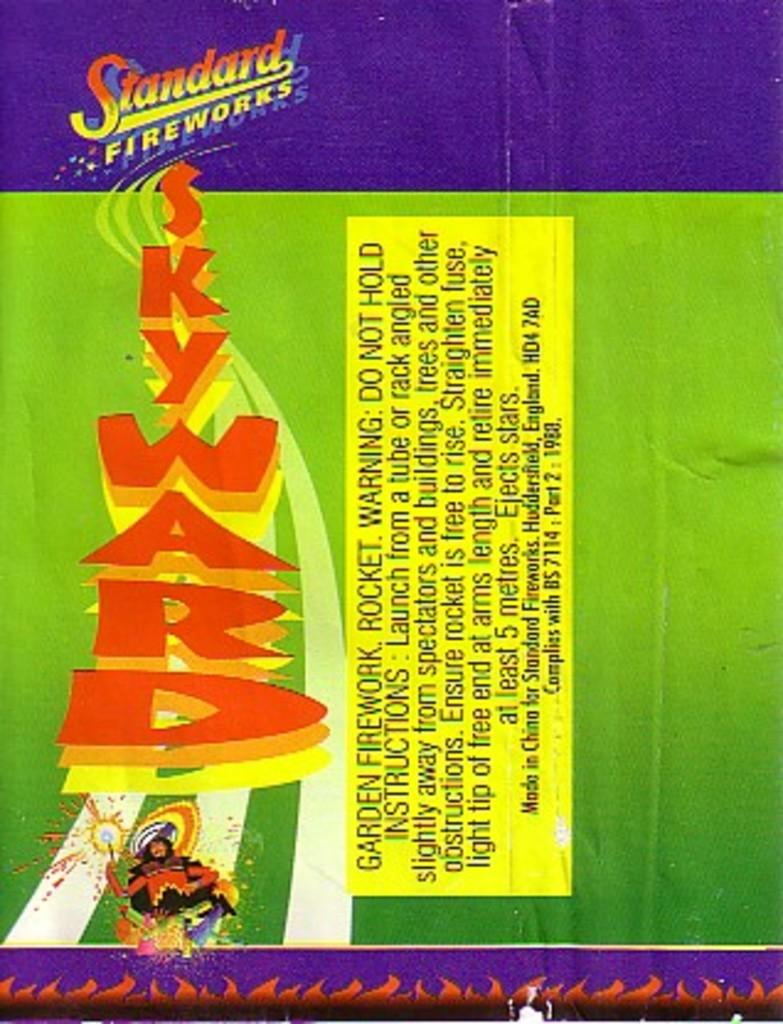<image>
Describe the image concisely. A close up view of a fireworks package which reads Standard Fireworks. 